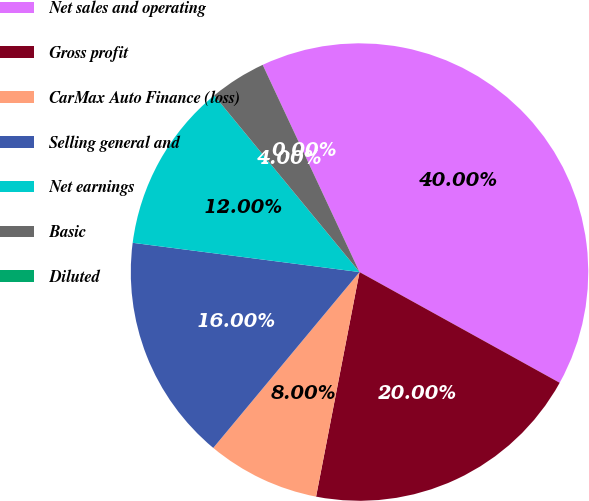Convert chart. <chart><loc_0><loc_0><loc_500><loc_500><pie_chart><fcel>Net sales and operating<fcel>Gross profit<fcel>CarMax Auto Finance (loss)<fcel>Selling general and<fcel>Net earnings<fcel>Basic<fcel>Diluted<nl><fcel>40.0%<fcel>20.0%<fcel>8.0%<fcel>16.0%<fcel>12.0%<fcel>4.0%<fcel>0.0%<nl></chart> 